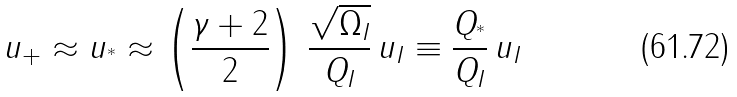Convert formula to latex. <formula><loc_0><loc_0><loc_500><loc_500>u _ { + } \approx u _ { ^ { * } } \approx \left ( \frac { \gamma + 2 } { 2 } \right ) \, \frac { \sqrt { \Omega _ { I } } } { Q _ { I } } \, u _ { I } \equiv \frac { Q _ { ^ { * } } } { Q _ { I } } \, u _ { I }</formula> 